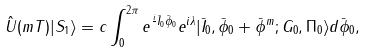<formula> <loc_0><loc_0><loc_500><loc_500>\hat { U } ( m T ) | S _ { 1 } \rangle = c \int _ { 0 } ^ { 2 \pi } e ^ { \frac { i } { } \bar { I } _ { 0 } \bar { \phi } _ { 0 } } e ^ { i \lambda } | \bar { I } _ { 0 } , \bar { \phi } _ { 0 } + \bar { \phi } ^ { m } ; G _ { 0 } , \Pi _ { 0 } \rangle d \bar { \phi } _ { 0 } ,</formula> 